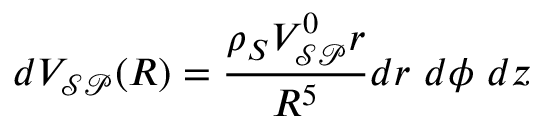Convert formula to latex. <formula><loc_0><loc_0><loc_500><loc_500>d V _ { \mathcal { S P } } ( R ) = \frac { \rho _ { S } V _ { \mathcal { S P } } ^ { 0 } r } { R ^ { 5 } } d r d \phi d z</formula> 